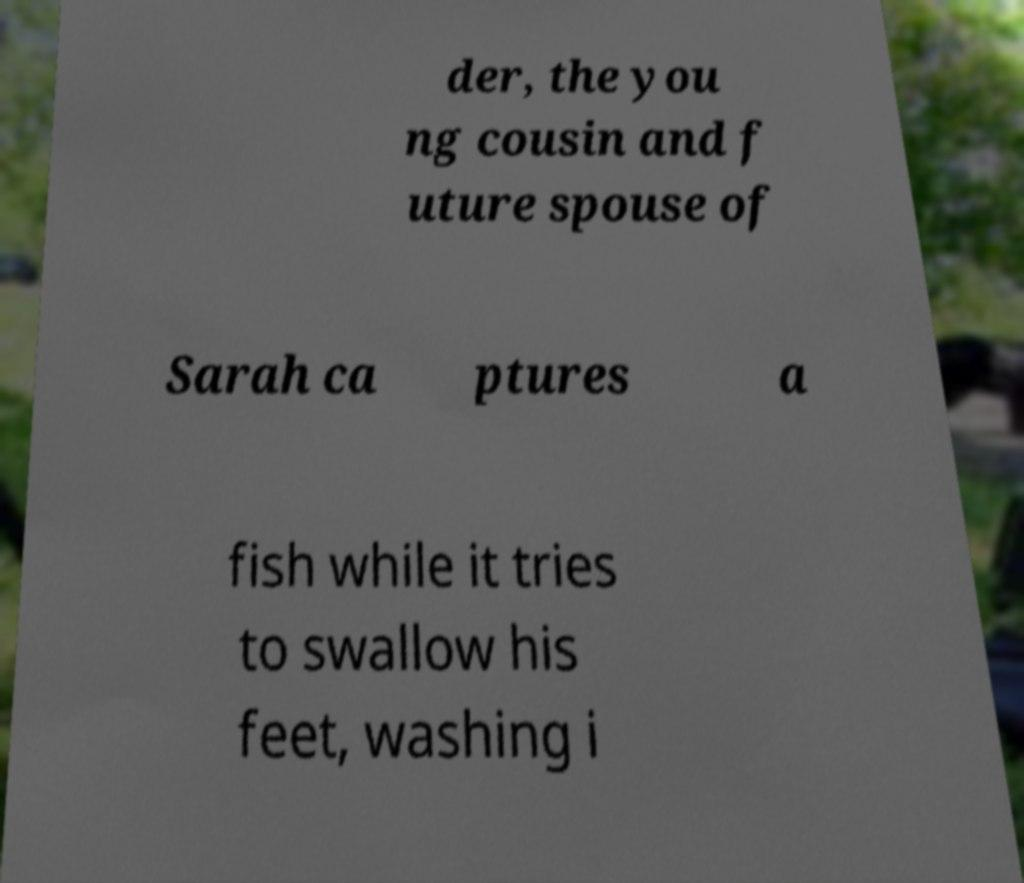Can you read and provide the text displayed in the image?This photo seems to have some interesting text. Can you extract and type it out for me? der, the you ng cousin and f uture spouse of Sarah ca ptures a fish while it tries to swallow his feet, washing i 